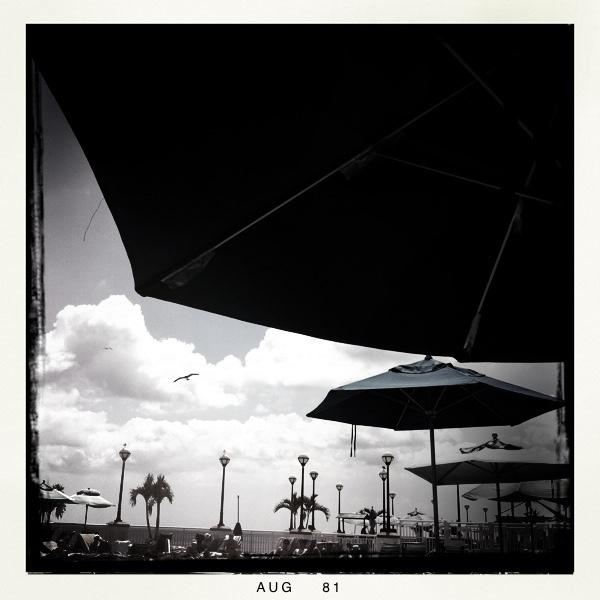Which US state is most likely to contain palm trees like the ones contained in this image? florida 